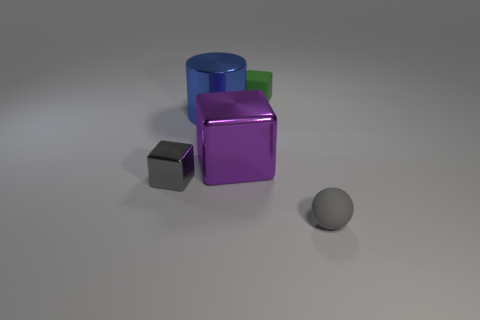Add 3 large green objects. How many objects exist? 8 Subtract all cylinders. How many objects are left? 4 Add 2 purple cubes. How many purple cubes are left? 3 Add 5 small matte things. How many small matte things exist? 7 Subtract 0 gray cylinders. How many objects are left? 5 Subtract all green matte balls. Subtract all purple metal things. How many objects are left? 4 